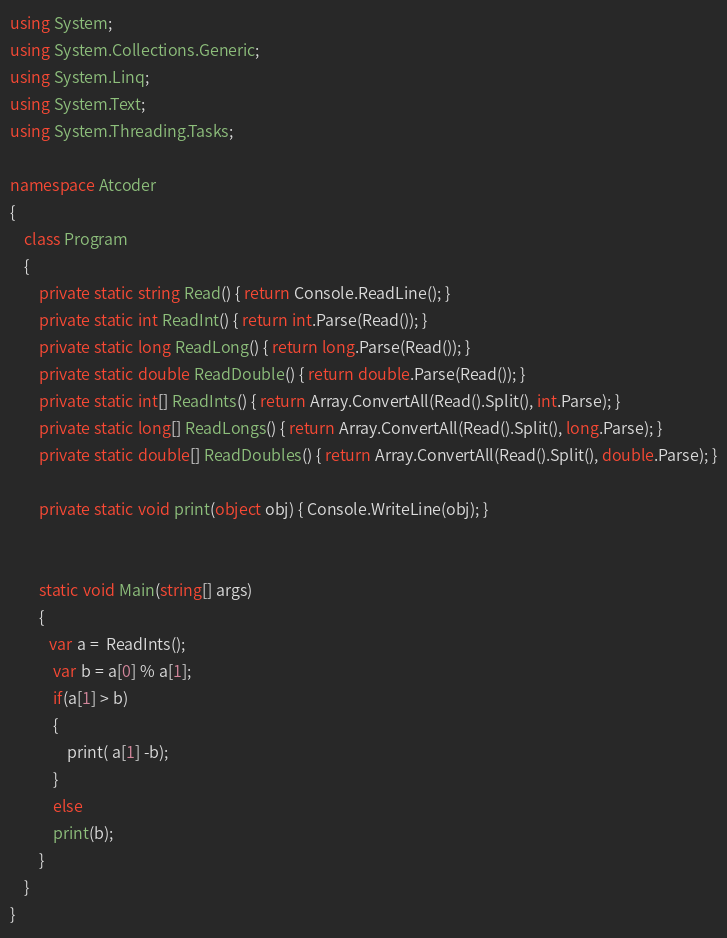<code> <loc_0><loc_0><loc_500><loc_500><_C#_>using System;
using System.Collections.Generic;
using System.Linq;
using System.Text;
using System.Threading.Tasks;

namespace Atcoder
{
    class Program
    {
        private static string Read() { return Console.ReadLine(); }
        private static int ReadInt() { return int.Parse(Read()); }
        private static long ReadLong() { return long.Parse(Read()); }
        private static double ReadDouble() { return double.Parse(Read()); }
        private static int[] ReadInts() { return Array.ConvertAll(Read().Split(), int.Parse); }
        private static long[] ReadLongs() { return Array.ConvertAll(Read().Split(), long.Parse); }
        private static double[] ReadDoubles() { return Array.ConvertAll(Read().Split(), double.Parse); }

        private static void print(object obj) { Console.WriteLine(obj); }


        static void Main(string[] args)
        {
           var a =  ReadInts();
            var b = a[0] % a[1];
            if(a[1] > b)
            {
                print( a[1] -b);
            }
            else
            print(b);
        }
    }
}</code> 